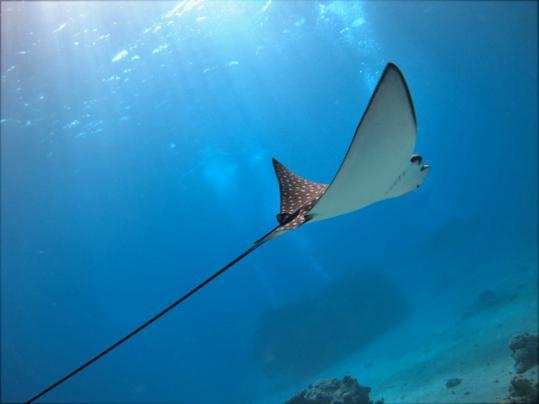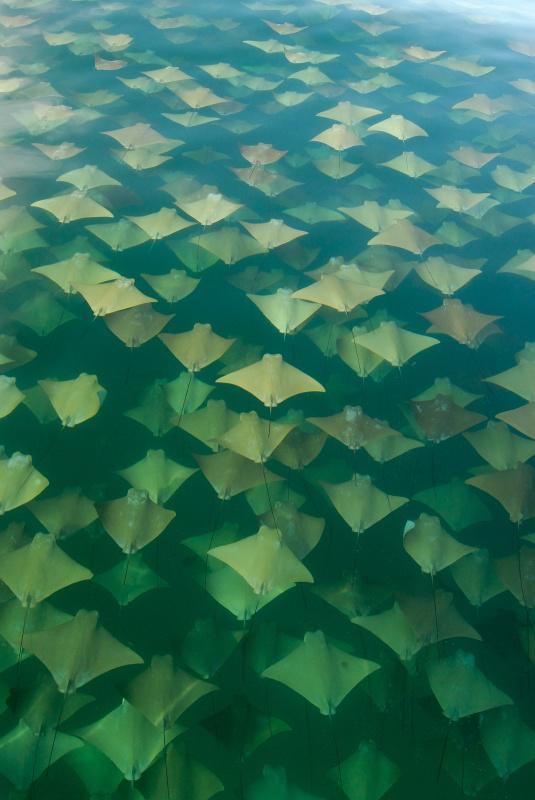The first image is the image on the left, the second image is the image on the right. Examine the images to the left and right. Is the description "There is a group of stingrays in the water." accurate? Answer yes or no. Yes. The first image is the image on the left, the second image is the image on the right. Evaluate the accuracy of this statement regarding the images: "There is one spotted eagle ray.". Is it true? Answer yes or no. Yes. 